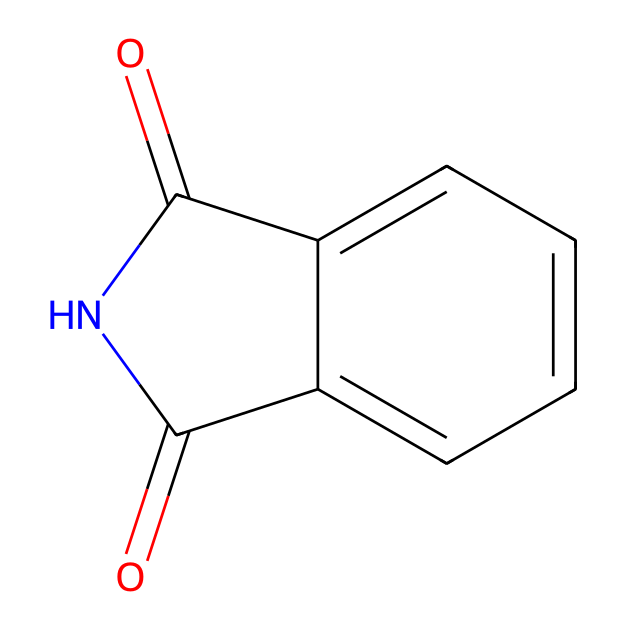What is the chemical name of the compound represented by the SMILES? The SMILES representation corresponds to a specific chemical structure, which is phthalimide. This structure contains carbonyl (C=O) and nitrogen functionalities typical of imides.
Answer: phthalimide How many nitrogen atoms are in the molecule? By analyzing the chemical structure, there is one nitrogen atom present in the phthalimide. It can be identified in the cyclic structure where the nitrogen is part of the imide functionality.
Answer: 1 What is the total number of carbon atoms in phthalimide? The structure shows a total of 8 carbon atoms: 6 from the phenyl ring and 2 from the carbonyl groups. Counting each carbon in the structure gives this total.
Answer: 8 Which functional groups are present in this compound? The molecule exhibits an imide functional group, characterized by the carbonyl (C=O) attached to a nitrogen atom. The presence of two carbonyl groups confirms this classification.
Answer: imide Is phthalimide aromatic in nature? Yes, phthalimide contains a phenyl ring, which is aromatic due to its cyclic structure with alternating double bonds, fulfilling Huckel's rule of aromaticity.
Answer: yes How many double bonds are in the structure? In the structure, there are two double bonds present, both associated with the carbonyl groups. Each carbonyl has one double bond with oxygen.
Answer: 2 What type of compound is phthalimide classified as? Phthalimide is classified as an imide, as it contains the nitrogen atom bonded to a carbonyl group, which is a defining trait of imides and distinguishes it from other compound types.
Answer: imide 